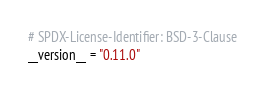Convert code to text. <code><loc_0><loc_0><loc_500><loc_500><_Python_># SPDX-License-Identifier: BSD-3-Clause
__version__ = "0.11.0"
</code> 